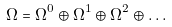Convert formula to latex. <formula><loc_0><loc_0><loc_500><loc_500>\Omega = \Omega ^ { 0 } \oplus \Omega ^ { 1 } \oplus \Omega ^ { 2 } \oplus \dots</formula> 